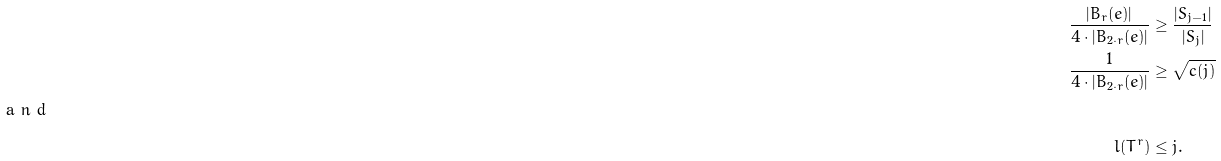Convert formula to latex. <formula><loc_0><loc_0><loc_500><loc_500>\frac { | B _ { r } ( e ) | } { 4 \cdot | B _ { 2 \cdot r } ( e ) | } & \geq \frac { | S _ { j - 1 } | } { | S _ { j } | } \\ \frac { 1 } { 4 \cdot | B _ { 2 \cdot r } ( e ) | } & \geq \sqrt { c ( j ) } \\ \intertext { a n d } l ( T ^ { r } ) & \leq j .</formula> 